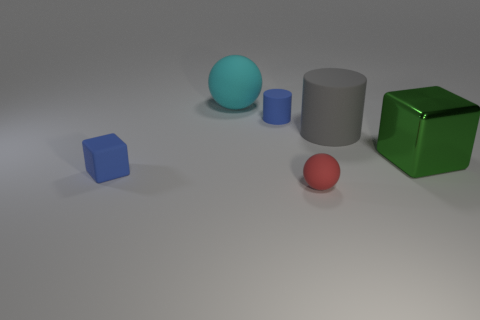What number of small objects have the same color as the rubber cube?
Make the answer very short. 1. There is a gray cylinder that is made of the same material as the tiny blue block; what is its size?
Your response must be concise. Large. Do the ball behind the green shiny object and the blue matte object in front of the green thing have the same size?
Offer a terse response. No. How many objects are big brown metal cylinders or large matte cylinders?
Offer a terse response. 1. The shiny object is what shape?
Keep it short and to the point. Cube. There is another matte thing that is the same shape as the tiny red object; what size is it?
Your answer should be compact. Large. Is there any other thing that is the same material as the large green object?
Your answer should be very brief. No. There is a block on the right side of the ball that is behind the tiny cylinder; what size is it?
Your answer should be compact. Large. Are there the same number of cyan objects that are in front of the large cyan sphere and tiny rubber spheres?
Your answer should be compact. No. How many other things are there of the same color as the matte block?
Offer a terse response. 1. 